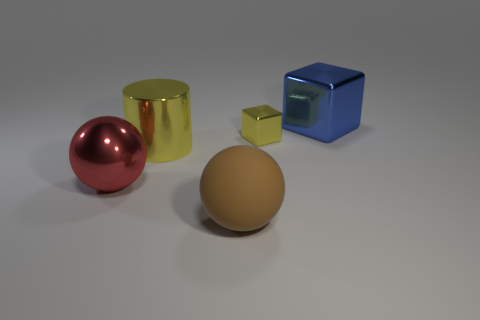Add 5 small metallic blocks. How many objects exist? 10 Subtract all blocks. How many objects are left? 3 Add 4 large brown spheres. How many large brown spheres exist? 5 Subtract 0 red blocks. How many objects are left? 5 Subtract all small things. Subtract all yellow objects. How many objects are left? 2 Add 2 balls. How many balls are left? 4 